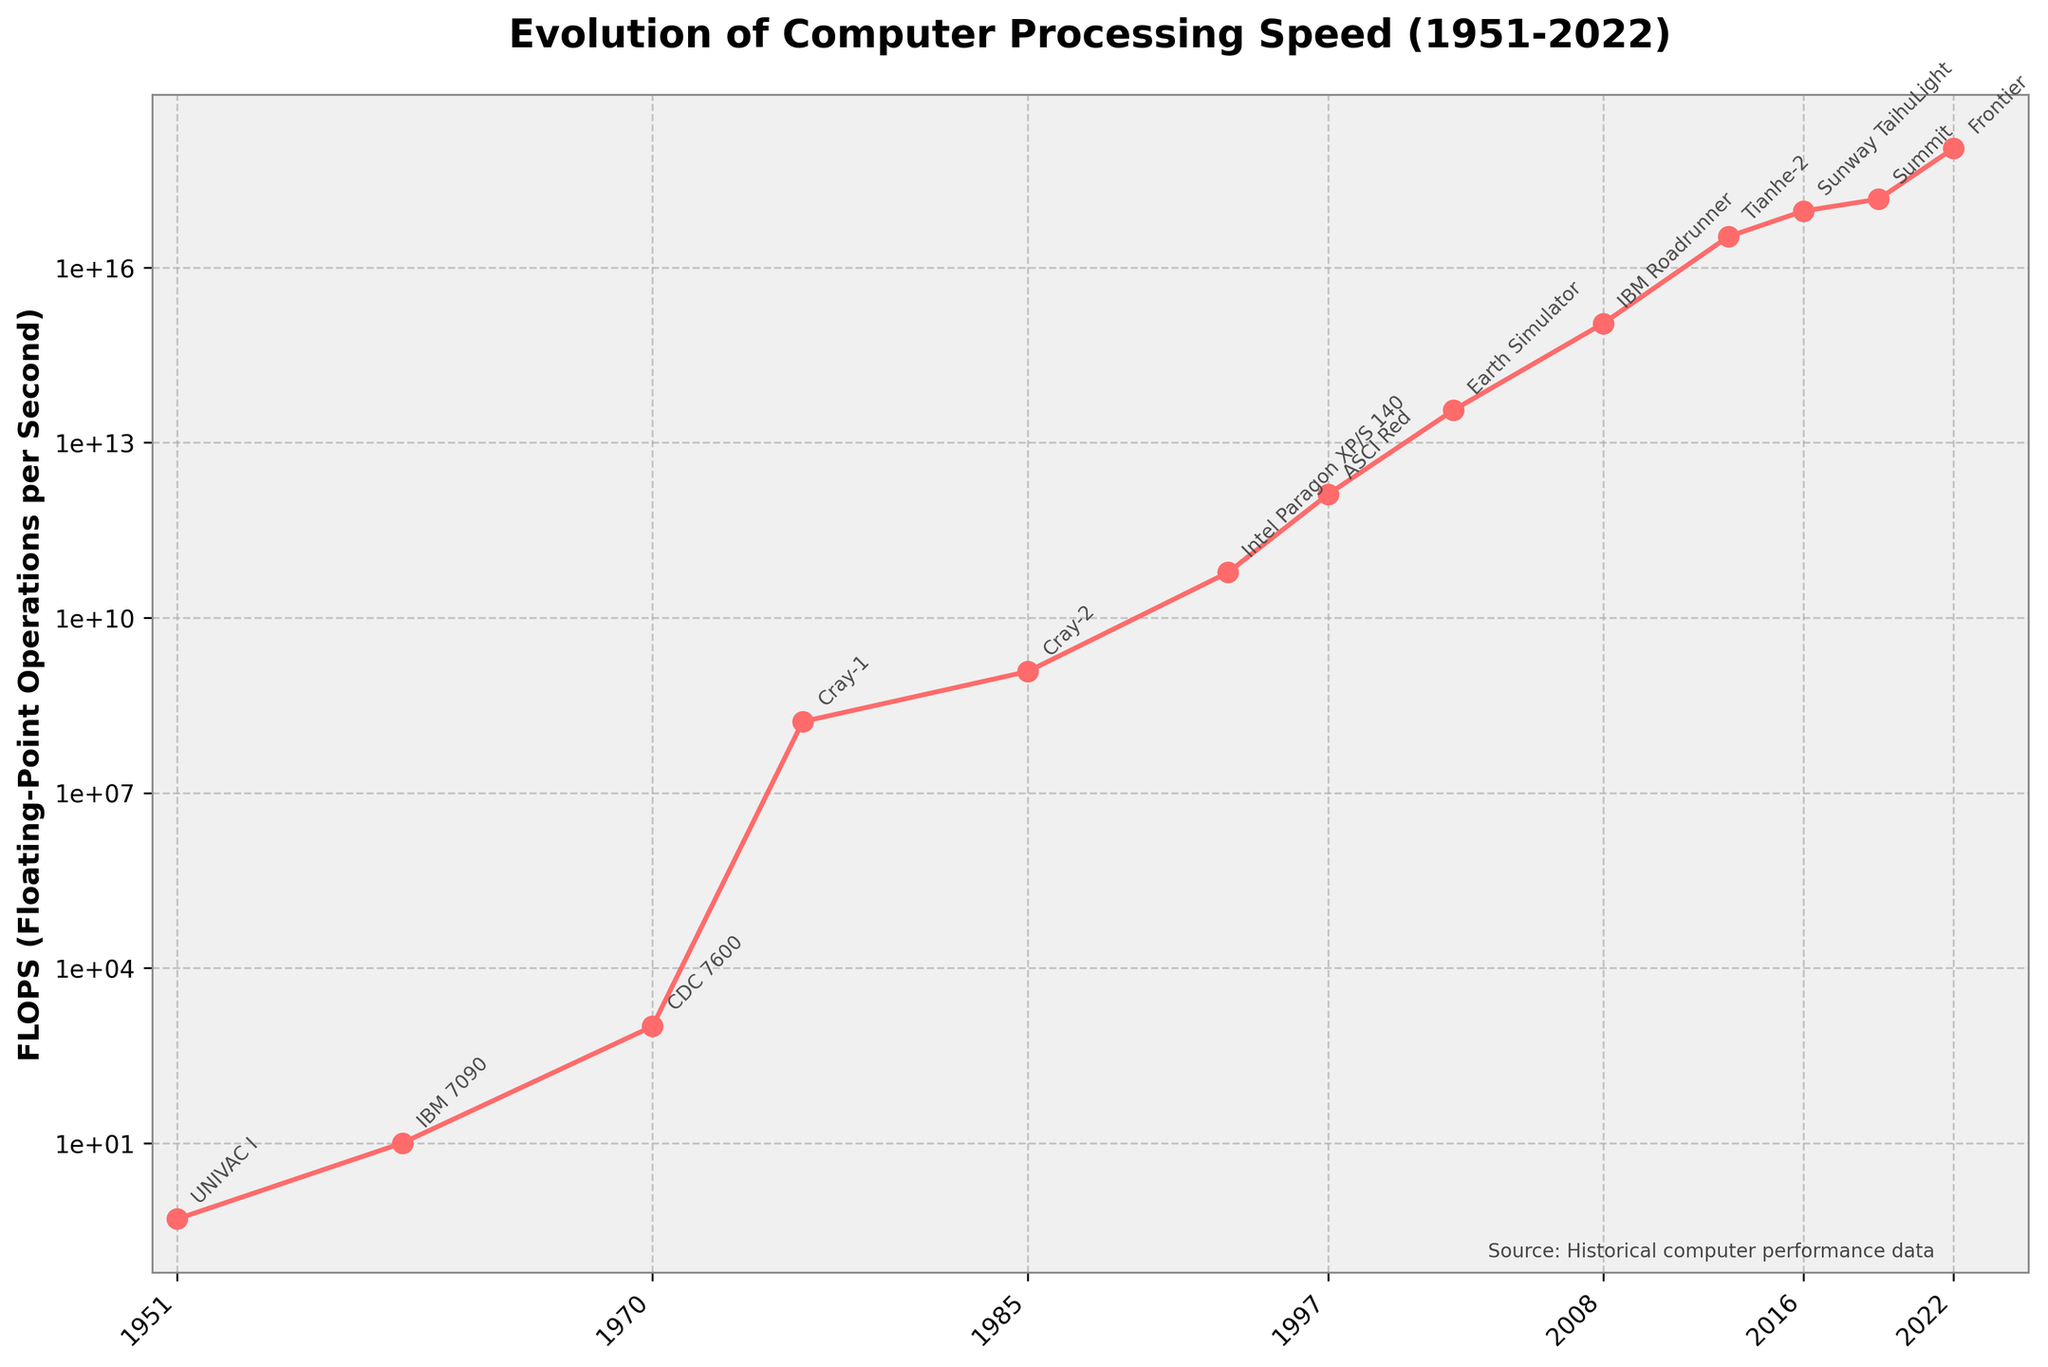What was the FLOPS performance of computers in 1970 and 1997, and which had the higher speed? Look at the plot points for 1970 and 1997. In 1970, the FLOPS is 1,000, and in 1997, it is 1,300,000,000,000. 1997 had a higher processing speed.
Answer: 1997 Which computer had the highest FLOPS as per the plot, and in what year? The highest point on the line chart indicates the highest FLOPS, which is Frontier in 2022.
Answer: Frontier in 2022 How many times did the FLOPS increase from the UNIVAC I in 1951 to the Cray-1 in 1976? First, find the FLOPS in 1951 (0.5) and 1976 (166,000,000). Then, calculate the ratio: 166,000,000 / 0.5 = 332,000,000 times.
Answer: 332,000,000 times Between which two years did the largest increase in FLOPS occur? Compare the FLOPS values year by year. The largest single increase is between 2019 (Summit) and 2022 (Frontier): 1,102,000,000,000,000,000 - 148,600,000,000,000,000 = 953,400,000,000,000,000.
Answer: 2019 and 2022 What is the median value of the FLOPS on the chart? List the FLOPS values in ascending order and find the middle value. The ordered values are [0.5, 10, 1,000, 166,000,000, 1,200,000,000, 59,700,000,000, 1,300,000,000,000, 35,860,000,000,000, 1,105,000,000,000,000, 33,862,700,000,000,000, 93,014,600,000,000,000, 148,600,000,000,000,000, 1,102,000,000,000,000,000]. The median value is the 7th value: 1,300,000,000,000.
Answer: 1,300,000,000,000 Which computer represented the biggest leap in FLOPS compared to its predecessor? A detailed comparison between successive years shows the biggest leap is from Intel Paragon XP/S 140 in 1993 to ASCI Red in 1997: 1,300,000,000,000 - 59,700,000,000 = 1,240,300,000,000.
Answer: ASCI Red in 1997 How does the processing speed of IBM Roadrunner in 2008 compare to the CDC 7600 in 1970? From the plot, the FLOPS of IBM Roadrunner in 2008 is 1,105,000,000,000,000, and for CDC 7600 in 1970 it is 1,000. The ratio is 1,105,000,000,000,000 / 1,000 = 1,105,000,000 times greater.
Answer: 1,105,000,000 times In which decade did the FLOPS increase by more than a million times? Analyze decade-over-decade increases. From the 1960s (IBM 7090) to the 1970s (CDC 7600), the increase was from 10 to 1,000 (100x); from the 1970s to 1980s (Cray-1 to Cray-2), from 1,000 to 1,200,000,000 (1,200,000x). Hence, the FLOPS increased by more than a million times in the 1970s.
Answer: 1970s 